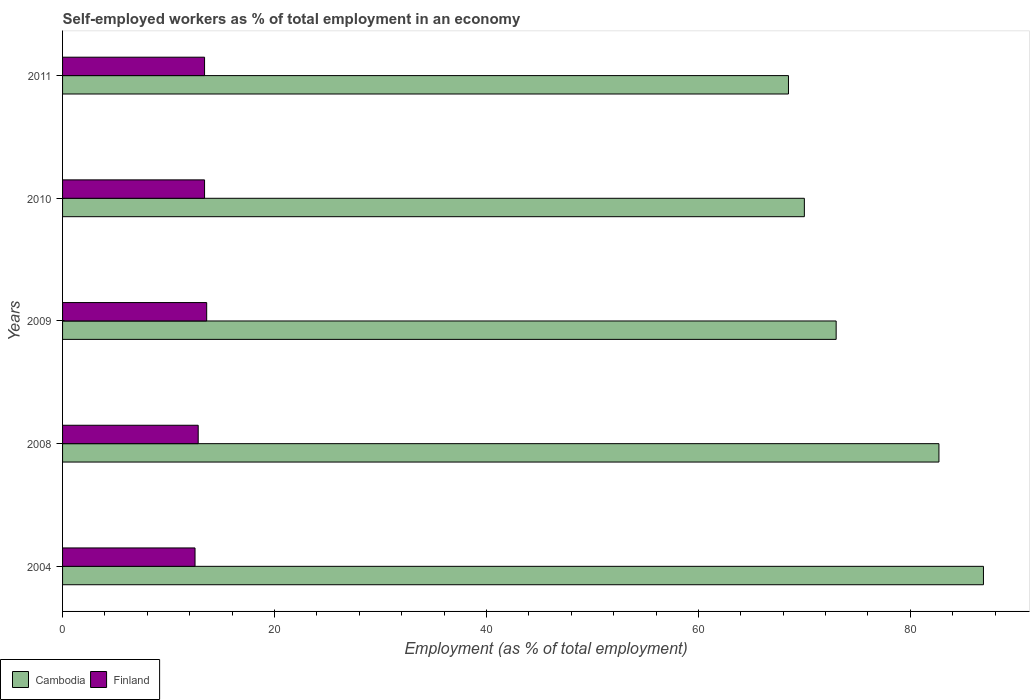Are the number of bars per tick equal to the number of legend labels?
Offer a very short reply. Yes. How many bars are there on the 2nd tick from the top?
Provide a short and direct response. 2. In how many cases, is the number of bars for a given year not equal to the number of legend labels?
Ensure brevity in your answer.  0. What is the percentage of self-employed workers in Finland in 2008?
Provide a short and direct response. 12.8. Across all years, what is the maximum percentage of self-employed workers in Finland?
Your response must be concise. 13.6. Across all years, what is the minimum percentage of self-employed workers in Cambodia?
Your answer should be very brief. 68.5. What is the total percentage of self-employed workers in Cambodia in the graph?
Offer a very short reply. 381.1. What is the difference between the percentage of self-employed workers in Finland in 2009 and that in 2010?
Your response must be concise. 0.2. What is the difference between the percentage of self-employed workers in Finland in 2010 and the percentage of self-employed workers in Cambodia in 2008?
Make the answer very short. -69.3. What is the average percentage of self-employed workers in Cambodia per year?
Provide a succinct answer. 76.22. In the year 2010, what is the difference between the percentage of self-employed workers in Finland and percentage of self-employed workers in Cambodia?
Offer a terse response. -56.6. What is the ratio of the percentage of self-employed workers in Finland in 2008 to that in 2011?
Make the answer very short. 0.96. Is the difference between the percentage of self-employed workers in Finland in 2009 and 2010 greater than the difference between the percentage of self-employed workers in Cambodia in 2009 and 2010?
Your answer should be very brief. No. What is the difference between the highest and the second highest percentage of self-employed workers in Cambodia?
Your answer should be compact. 4.2. What is the difference between the highest and the lowest percentage of self-employed workers in Cambodia?
Your response must be concise. 18.4. In how many years, is the percentage of self-employed workers in Cambodia greater than the average percentage of self-employed workers in Cambodia taken over all years?
Give a very brief answer. 2. Is the sum of the percentage of self-employed workers in Cambodia in 2004 and 2010 greater than the maximum percentage of self-employed workers in Finland across all years?
Provide a short and direct response. Yes. What does the 1st bar from the top in 2008 represents?
Provide a short and direct response. Finland. What does the 1st bar from the bottom in 2011 represents?
Your response must be concise. Cambodia. How many bars are there?
Provide a short and direct response. 10. How many years are there in the graph?
Give a very brief answer. 5. What is the difference between two consecutive major ticks on the X-axis?
Ensure brevity in your answer.  20. Are the values on the major ticks of X-axis written in scientific E-notation?
Offer a terse response. No. Does the graph contain grids?
Your answer should be compact. No. How many legend labels are there?
Your answer should be very brief. 2. How are the legend labels stacked?
Give a very brief answer. Horizontal. What is the title of the graph?
Ensure brevity in your answer.  Self-employed workers as % of total employment in an economy. Does "High income: OECD" appear as one of the legend labels in the graph?
Your answer should be very brief. No. What is the label or title of the X-axis?
Offer a terse response. Employment (as % of total employment). What is the label or title of the Y-axis?
Your response must be concise. Years. What is the Employment (as % of total employment) of Cambodia in 2004?
Provide a succinct answer. 86.9. What is the Employment (as % of total employment) of Cambodia in 2008?
Provide a short and direct response. 82.7. What is the Employment (as % of total employment) in Finland in 2008?
Offer a terse response. 12.8. What is the Employment (as % of total employment) in Finland in 2009?
Give a very brief answer. 13.6. What is the Employment (as % of total employment) in Cambodia in 2010?
Offer a terse response. 70. What is the Employment (as % of total employment) of Finland in 2010?
Offer a very short reply. 13.4. What is the Employment (as % of total employment) in Cambodia in 2011?
Make the answer very short. 68.5. What is the Employment (as % of total employment) of Finland in 2011?
Your answer should be very brief. 13.4. Across all years, what is the maximum Employment (as % of total employment) of Cambodia?
Keep it short and to the point. 86.9. Across all years, what is the maximum Employment (as % of total employment) of Finland?
Provide a succinct answer. 13.6. Across all years, what is the minimum Employment (as % of total employment) of Cambodia?
Make the answer very short. 68.5. What is the total Employment (as % of total employment) in Cambodia in the graph?
Your answer should be very brief. 381.1. What is the total Employment (as % of total employment) of Finland in the graph?
Make the answer very short. 65.7. What is the difference between the Employment (as % of total employment) of Cambodia in 2004 and that in 2008?
Provide a succinct answer. 4.2. What is the difference between the Employment (as % of total employment) in Cambodia in 2004 and that in 2009?
Your answer should be compact. 13.9. What is the difference between the Employment (as % of total employment) of Cambodia in 2004 and that in 2010?
Provide a succinct answer. 16.9. What is the difference between the Employment (as % of total employment) in Finland in 2004 and that in 2011?
Give a very brief answer. -0.9. What is the difference between the Employment (as % of total employment) in Finland in 2008 and that in 2009?
Offer a very short reply. -0.8. What is the difference between the Employment (as % of total employment) in Cambodia in 2008 and that in 2011?
Keep it short and to the point. 14.2. What is the difference between the Employment (as % of total employment) of Finland in 2008 and that in 2011?
Offer a terse response. -0.6. What is the difference between the Employment (as % of total employment) in Cambodia in 2009 and that in 2010?
Make the answer very short. 3. What is the difference between the Employment (as % of total employment) in Cambodia in 2009 and that in 2011?
Make the answer very short. 4.5. What is the difference between the Employment (as % of total employment) of Finland in 2009 and that in 2011?
Provide a short and direct response. 0.2. What is the difference between the Employment (as % of total employment) in Cambodia in 2010 and that in 2011?
Provide a short and direct response. 1.5. What is the difference between the Employment (as % of total employment) of Finland in 2010 and that in 2011?
Provide a succinct answer. 0. What is the difference between the Employment (as % of total employment) of Cambodia in 2004 and the Employment (as % of total employment) of Finland in 2008?
Provide a succinct answer. 74.1. What is the difference between the Employment (as % of total employment) in Cambodia in 2004 and the Employment (as % of total employment) in Finland in 2009?
Give a very brief answer. 73.3. What is the difference between the Employment (as % of total employment) of Cambodia in 2004 and the Employment (as % of total employment) of Finland in 2010?
Provide a succinct answer. 73.5. What is the difference between the Employment (as % of total employment) of Cambodia in 2004 and the Employment (as % of total employment) of Finland in 2011?
Your answer should be very brief. 73.5. What is the difference between the Employment (as % of total employment) in Cambodia in 2008 and the Employment (as % of total employment) in Finland in 2009?
Make the answer very short. 69.1. What is the difference between the Employment (as % of total employment) of Cambodia in 2008 and the Employment (as % of total employment) of Finland in 2010?
Provide a short and direct response. 69.3. What is the difference between the Employment (as % of total employment) in Cambodia in 2008 and the Employment (as % of total employment) in Finland in 2011?
Provide a succinct answer. 69.3. What is the difference between the Employment (as % of total employment) in Cambodia in 2009 and the Employment (as % of total employment) in Finland in 2010?
Your answer should be compact. 59.6. What is the difference between the Employment (as % of total employment) of Cambodia in 2009 and the Employment (as % of total employment) of Finland in 2011?
Provide a short and direct response. 59.6. What is the difference between the Employment (as % of total employment) in Cambodia in 2010 and the Employment (as % of total employment) in Finland in 2011?
Provide a succinct answer. 56.6. What is the average Employment (as % of total employment) in Cambodia per year?
Your response must be concise. 76.22. What is the average Employment (as % of total employment) in Finland per year?
Keep it short and to the point. 13.14. In the year 2004, what is the difference between the Employment (as % of total employment) in Cambodia and Employment (as % of total employment) in Finland?
Make the answer very short. 74.4. In the year 2008, what is the difference between the Employment (as % of total employment) in Cambodia and Employment (as % of total employment) in Finland?
Provide a short and direct response. 69.9. In the year 2009, what is the difference between the Employment (as % of total employment) of Cambodia and Employment (as % of total employment) of Finland?
Your answer should be very brief. 59.4. In the year 2010, what is the difference between the Employment (as % of total employment) in Cambodia and Employment (as % of total employment) in Finland?
Ensure brevity in your answer.  56.6. In the year 2011, what is the difference between the Employment (as % of total employment) in Cambodia and Employment (as % of total employment) in Finland?
Ensure brevity in your answer.  55.1. What is the ratio of the Employment (as % of total employment) of Cambodia in 2004 to that in 2008?
Offer a very short reply. 1.05. What is the ratio of the Employment (as % of total employment) of Finland in 2004 to that in 2008?
Provide a short and direct response. 0.98. What is the ratio of the Employment (as % of total employment) of Cambodia in 2004 to that in 2009?
Your answer should be very brief. 1.19. What is the ratio of the Employment (as % of total employment) in Finland in 2004 to that in 2009?
Ensure brevity in your answer.  0.92. What is the ratio of the Employment (as % of total employment) in Cambodia in 2004 to that in 2010?
Offer a very short reply. 1.24. What is the ratio of the Employment (as % of total employment) in Finland in 2004 to that in 2010?
Your response must be concise. 0.93. What is the ratio of the Employment (as % of total employment) in Cambodia in 2004 to that in 2011?
Keep it short and to the point. 1.27. What is the ratio of the Employment (as % of total employment) in Finland in 2004 to that in 2011?
Your response must be concise. 0.93. What is the ratio of the Employment (as % of total employment) in Cambodia in 2008 to that in 2009?
Offer a very short reply. 1.13. What is the ratio of the Employment (as % of total employment) in Finland in 2008 to that in 2009?
Offer a very short reply. 0.94. What is the ratio of the Employment (as % of total employment) of Cambodia in 2008 to that in 2010?
Your answer should be very brief. 1.18. What is the ratio of the Employment (as % of total employment) in Finland in 2008 to that in 2010?
Offer a terse response. 0.96. What is the ratio of the Employment (as % of total employment) in Cambodia in 2008 to that in 2011?
Your answer should be very brief. 1.21. What is the ratio of the Employment (as % of total employment) in Finland in 2008 to that in 2011?
Provide a succinct answer. 0.96. What is the ratio of the Employment (as % of total employment) in Cambodia in 2009 to that in 2010?
Your response must be concise. 1.04. What is the ratio of the Employment (as % of total employment) in Finland in 2009 to that in 2010?
Keep it short and to the point. 1.01. What is the ratio of the Employment (as % of total employment) in Cambodia in 2009 to that in 2011?
Keep it short and to the point. 1.07. What is the ratio of the Employment (as % of total employment) in Finland in 2009 to that in 2011?
Ensure brevity in your answer.  1.01. What is the ratio of the Employment (as % of total employment) in Cambodia in 2010 to that in 2011?
Give a very brief answer. 1.02. What is the ratio of the Employment (as % of total employment) in Finland in 2010 to that in 2011?
Your answer should be compact. 1. What is the difference between the highest and the second highest Employment (as % of total employment) of Finland?
Make the answer very short. 0.2. What is the difference between the highest and the lowest Employment (as % of total employment) of Cambodia?
Your answer should be very brief. 18.4. What is the difference between the highest and the lowest Employment (as % of total employment) in Finland?
Offer a very short reply. 1.1. 